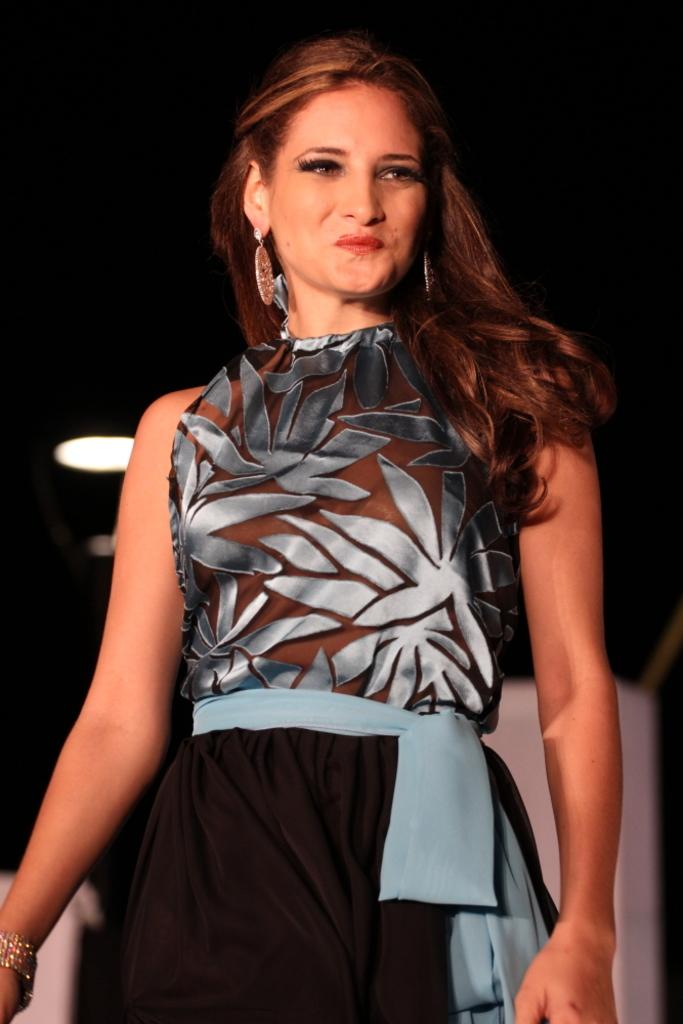Who is present in the image? There is a woman in the image. What is the woman wearing? The woman is wearing a black and blue color dress. Can you describe any accessories the woman is wearing? The woman is wearing jewelry. What type of rifle is the stranger holding in the image? There is no stranger or rifle present in the image; it features a woman wearing a black and blue color dress and jewelry. 